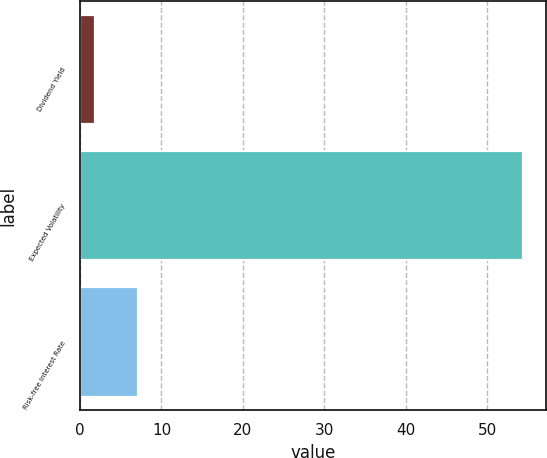Convert chart to OTSL. <chart><loc_0><loc_0><loc_500><loc_500><bar_chart><fcel>Dividend Yield<fcel>Expected Volatility<fcel>Risk-free Interest Rate<nl><fcel>1.81<fcel>54.44<fcel>7.07<nl></chart> 